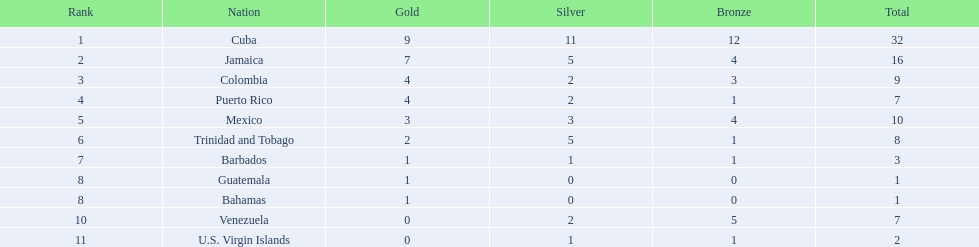What nation has achieved no less than 4 gold medals? Cuba, Jamaica, Colombia, Puerto Rico. Of these countries, who has the smallest quantity of bronze medals? Puerto Rico. 